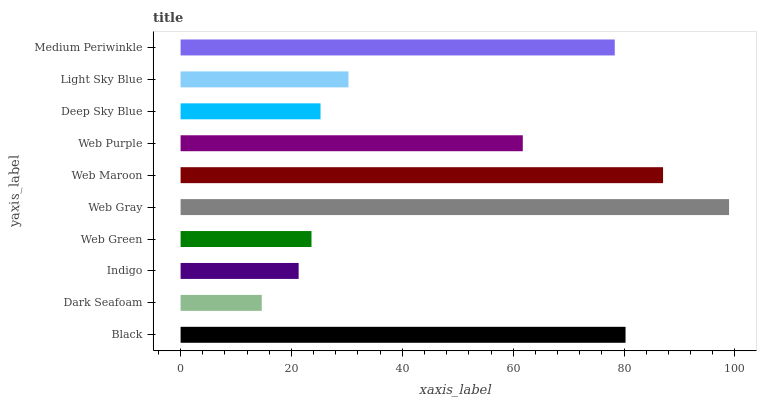Is Dark Seafoam the minimum?
Answer yes or no. Yes. Is Web Gray the maximum?
Answer yes or no. Yes. Is Indigo the minimum?
Answer yes or no. No. Is Indigo the maximum?
Answer yes or no. No. Is Indigo greater than Dark Seafoam?
Answer yes or no. Yes. Is Dark Seafoam less than Indigo?
Answer yes or no. Yes. Is Dark Seafoam greater than Indigo?
Answer yes or no. No. Is Indigo less than Dark Seafoam?
Answer yes or no. No. Is Web Purple the high median?
Answer yes or no. Yes. Is Light Sky Blue the low median?
Answer yes or no. Yes. Is Web Gray the high median?
Answer yes or no. No. Is Web Gray the low median?
Answer yes or no. No. 